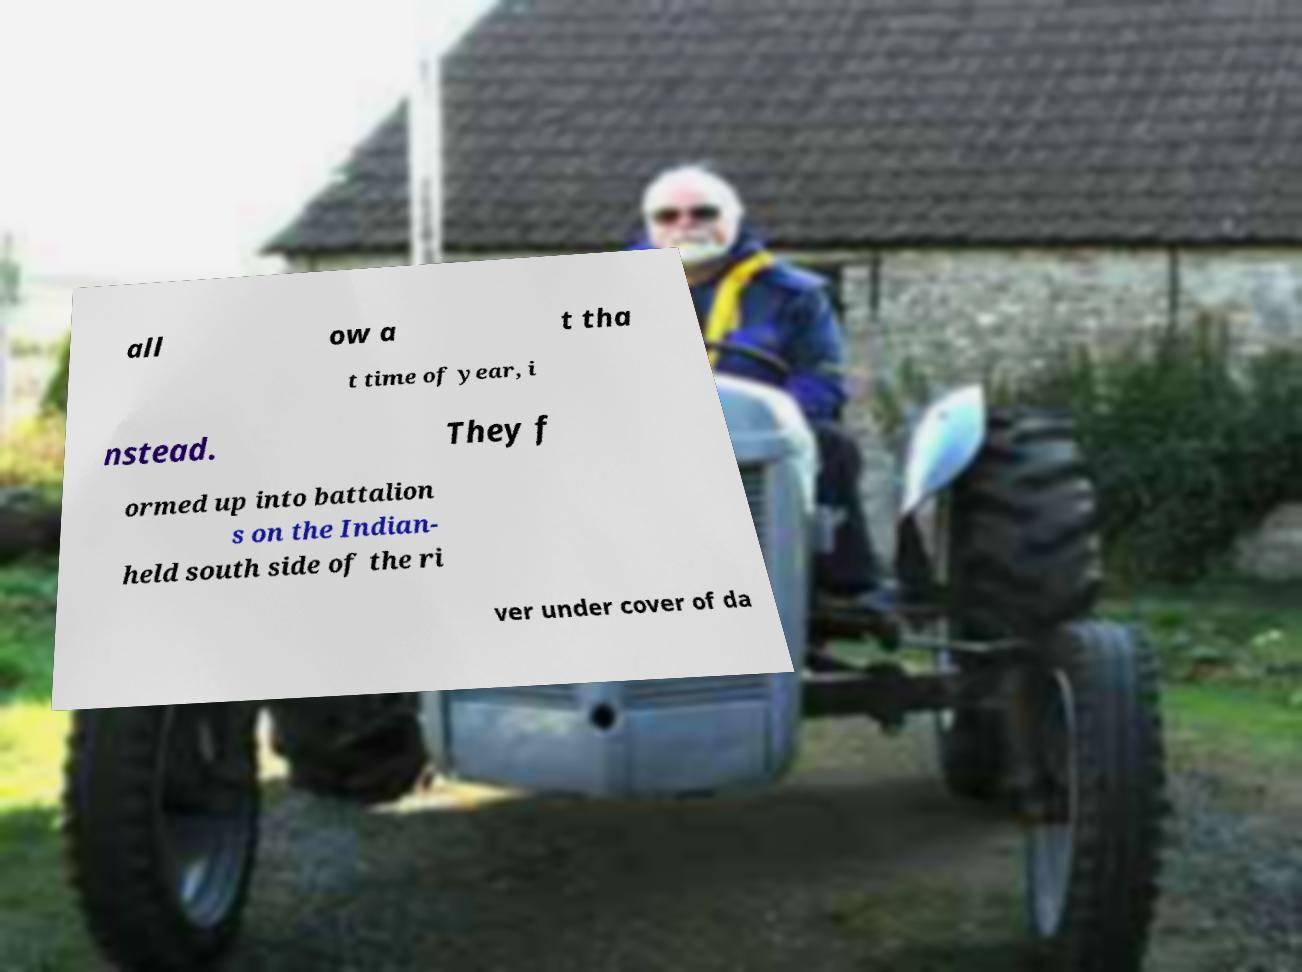Can you accurately transcribe the text from the provided image for me? all ow a t tha t time of year, i nstead. They f ormed up into battalion s on the Indian- held south side of the ri ver under cover of da 